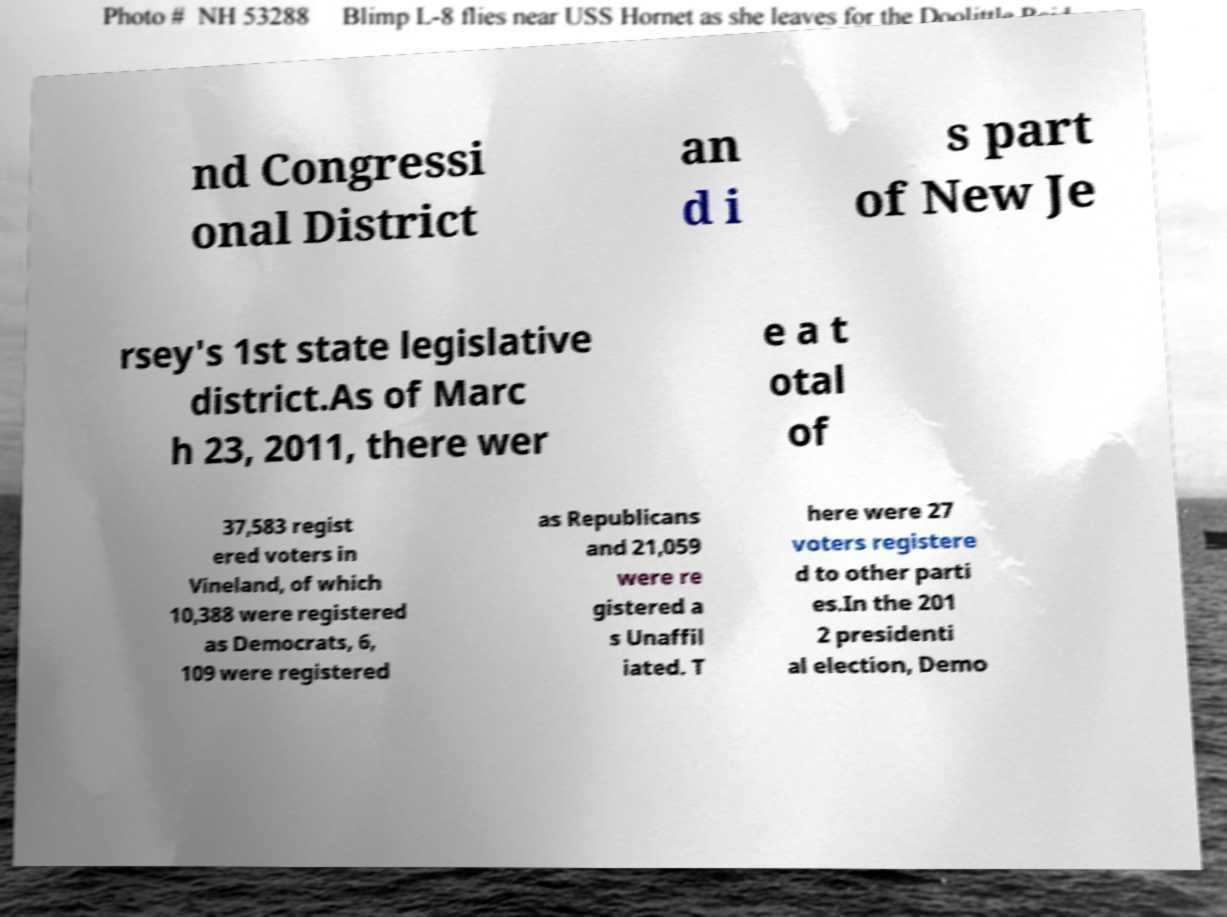Could you assist in decoding the text presented in this image and type it out clearly? nd Congressi onal District an d i s part of New Je rsey's 1st state legislative district.As of Marc h 23, 2011, there wer e a t otal of 37,583 regist ered voters in Vineland, of which 10,388 were registered as Democrats, 6, 109 were registered as Republicans and 21,059 were re gistered a s Unaffil iated. T here were 27 voters registere d to other parti es.In the 201 2 presidenti al election, Demo 